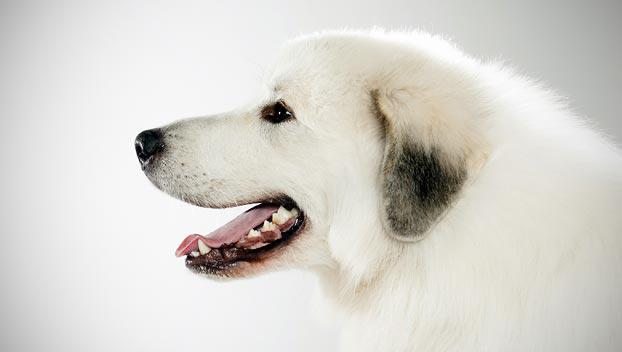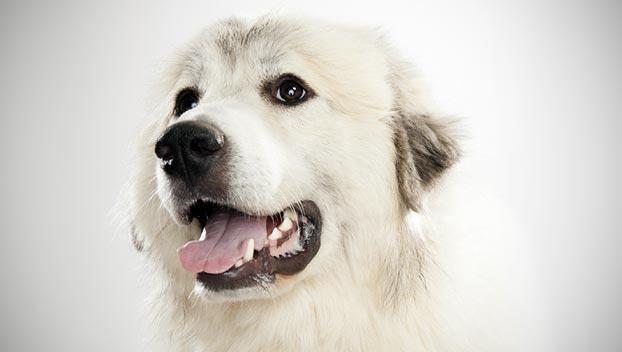The first image is the image on the left, the second image is the image on the right. Examine the images to the left and right. Is the description "There is a picture of the white dogs full body and not just his head." accurate? Answer yes or no. No. The first image is the image on the left, the second image is the image on the right. Given the left and right images, does the statement "One of the dogs is sitting in front of the sofa." hold true? Answer yes or no. No. 